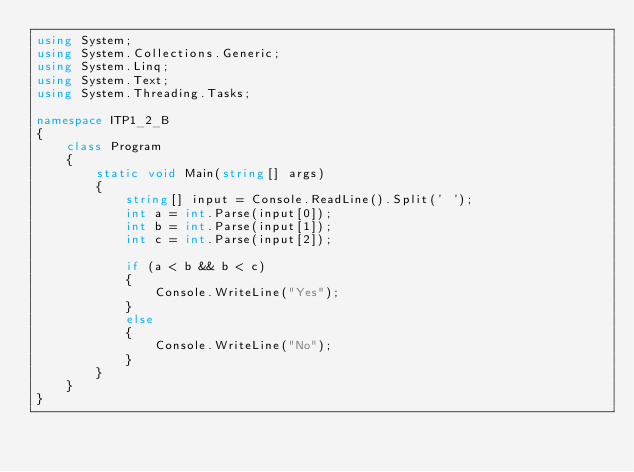<code> <loc_0><loc_0><loc_500><loc_500><_C#_>using System;
using System.Collections.Generic;
using System.Linq;
using System.Text;
using System.Threading.Tasks;

namespace ITP1_2_B
{
    class Program
    {
        static void Main(string[] args)
        {
            string[] input = Console.ReadLine().Split(' ');
            int a = int.Parse(input[0]);
            int b = int.Parse(input[1]);
            int c = int.Parse(input[2]);

            if (a < b && b < c)
            {
                Console.WriteLine("Yes");
            }
            else
            {
                Console.WriteLine("No");
            }
        }
    }
}

</code> 